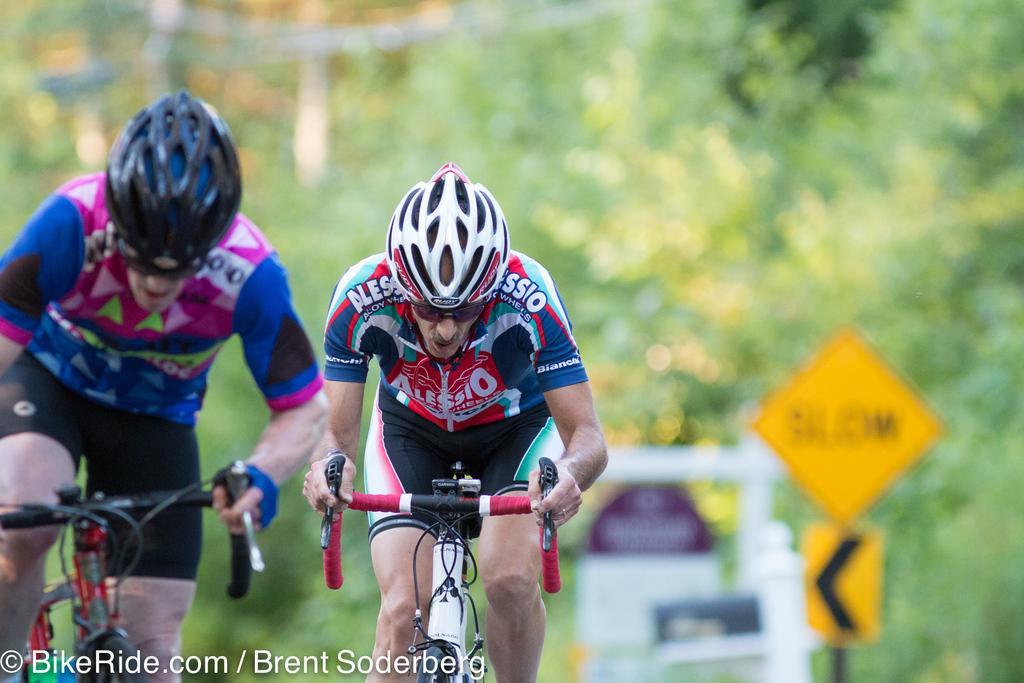In one or two sentences, can you explain what this image depicts? In this image there are two people riding a bicycle, at the bottom of the image there is some text, behind them there are a few banners and sign boards. The background is blurry. 